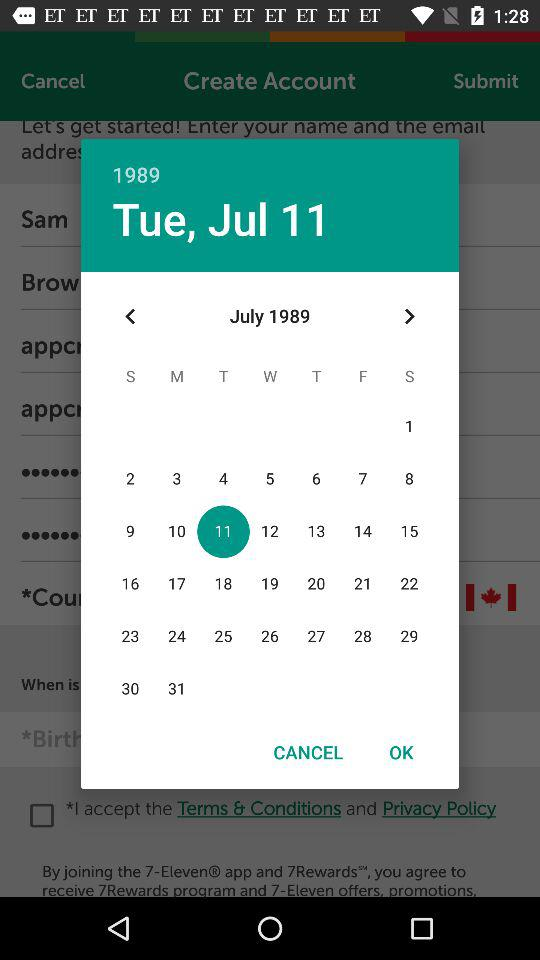What is the day on selected date? The day is Tuesday. 